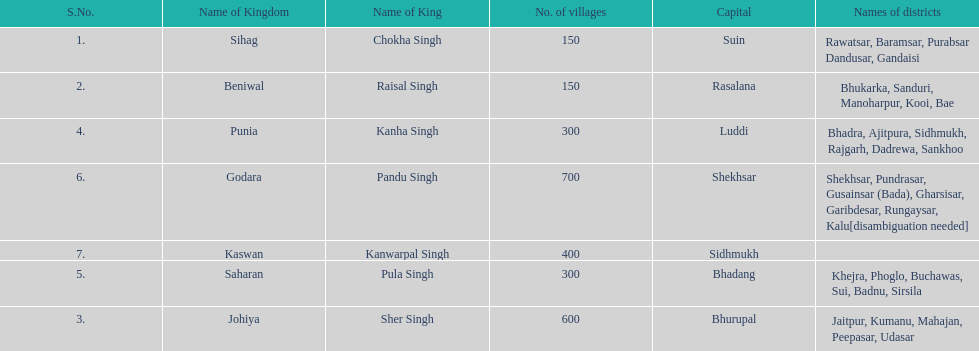What is the next kingdom listed after sihag? Beniwal. 